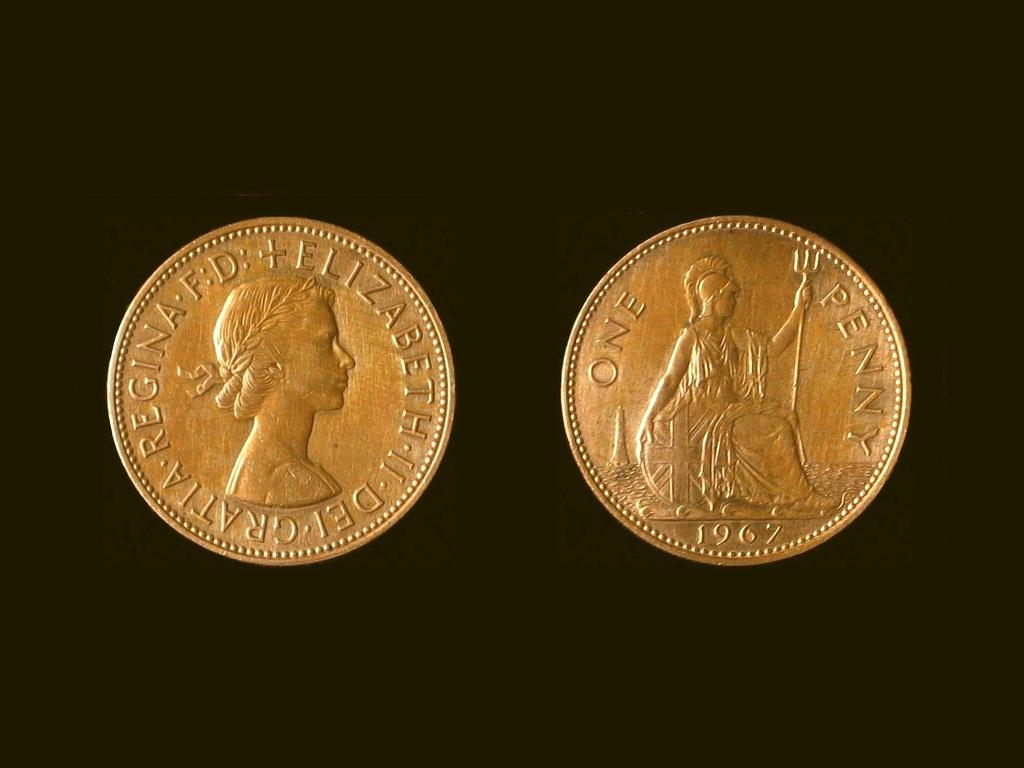<image>
Create a compact narrative representing the image presented. Two coins that say One Penny from 1967. 